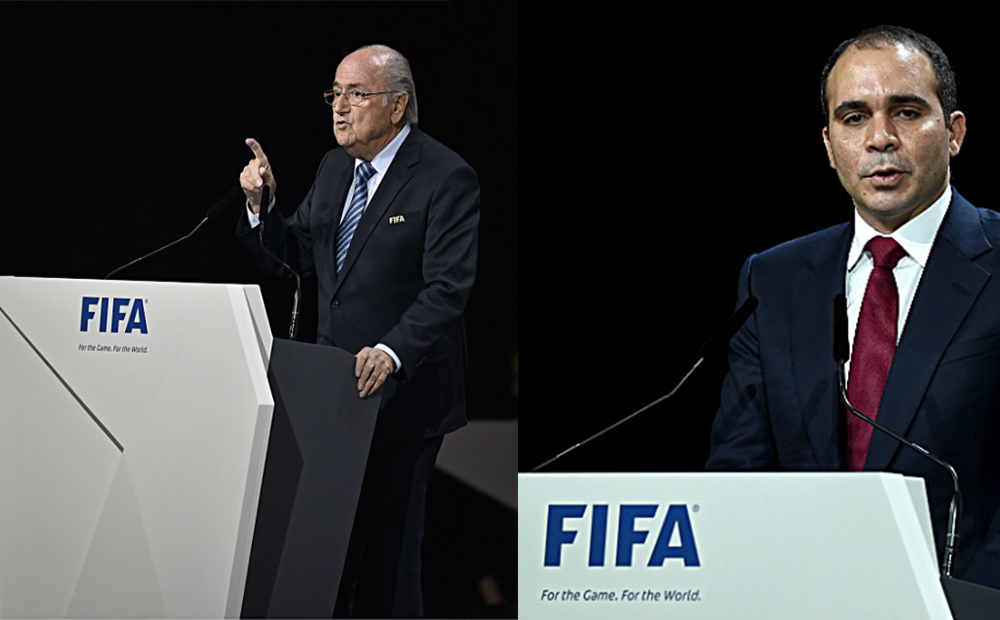What could be the significance of the different ways these two individuals are addressing the audience? The older individual's animated gesture suggests he is making a powerful point or rallying call, often seen in leaders driving a particular agenda. Meanwhile, the younger individual appears more measured and possibly analytical, perhaps presenting data or a strategic overview. Their contrasting approaches might cater to different segments of the audience, ensuring both emotional engagement and intellectual appeal. 